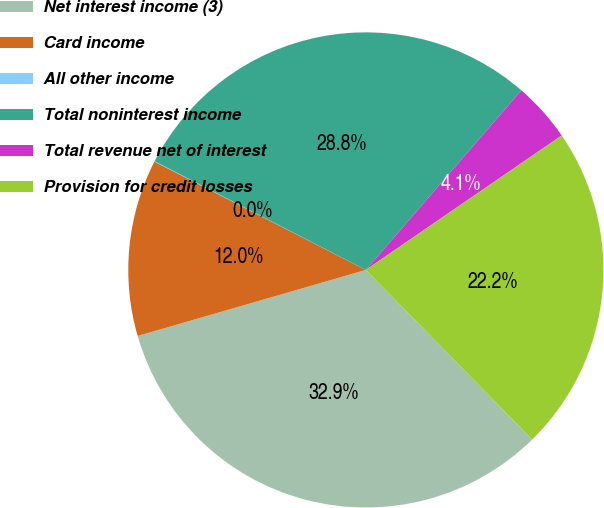Convert chart to OTSL. <chart><loc_0><loc_0><loc_500><loc_500><pie_chart><fcel>Net interest income (3)<fcel>Card income<fcel>All other income<fcel>Total noninterest income<fcel>Total revenue net of interest<fcel>Provision for credit losses<nl><fcel>32.86%<fcel>12.02%<fcel>0.03%<fcel>28.79%<fcel>4.07%<fcel>22.23%<nl></chart> 